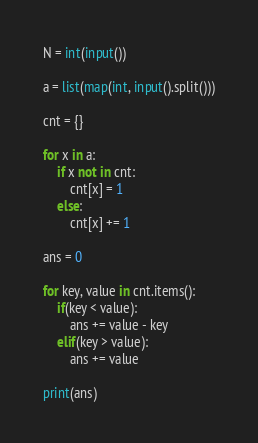<code> <loc_0><loc_0><loc_500><loc_500><_Python_>N = int(input())

a = list(map(int, input().split()))

cnt = {}

for x in a:
    if x not in cnt:
        cnt[x] = 1
    else:
        cnt[x] += 1

ans = 0

for key, value in cnt.items():
    if(key < value):
        ans += value - key
    elif(key > value):
        ans += value

print(ans)
</code> 